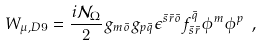Convert formula to latex. <formula><loc_0><loc_0><loc_500><loc_500>W _ { \mu , D 9 } = \frac { i \mathcal { N } _ { \Omega } } { 2 } g _ { m \bar { o } } g _ { p \bar { q } } \epsilon ^ { \bar { s } \bar { r } \bar { o } } f ^ { \bar { q } } _ { \bar { s } \bar { r } } \phi ^ { m } \phi ^ { p } \ ,</formula> 